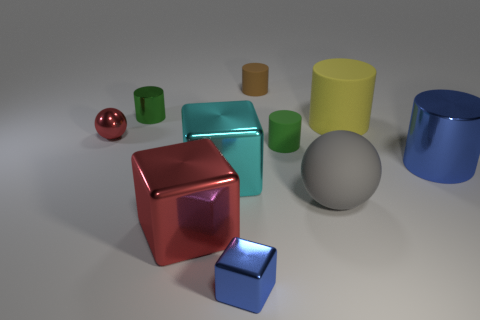There is a metal object that is on the right side of the cyan object and left of the yellow cylinder; what size is it?
Provide a succinct answer. Small. There is a red object behind the blue metal thing that is behind the small metal thing that is on the right side of the big red block; how big is it?
Provide a short and direct response. Small. What is the size of the yellow matte cylinder?
Your response must be concise. Large. There is a small green object to the right of the cube that is in front of the big red shiny thing; are there any big rubber things on the right side of it?
Give a very brief answer. Yes. How many small objects are metallic objects or metal spheres?
Offer a very short reply. 3. Are there any other things of the same color as the small metal block?
Make the answer very short. Yes. There is a brown object that is to the left of the blue cylinder; is its size the same as the shiny ball?
Provide a succinct answer. Yes. What color is the tiny matte cylinder that is behind the green cylinder in front of the metallic cylinder on the left side of the large cyan thing?
Offer a terse response. Brown. The large sphere has what color?
Your answer should be very brief. Gray. Does the tiny ball have the same color as the rubber sphere?
Provide a succinct answer. No. 